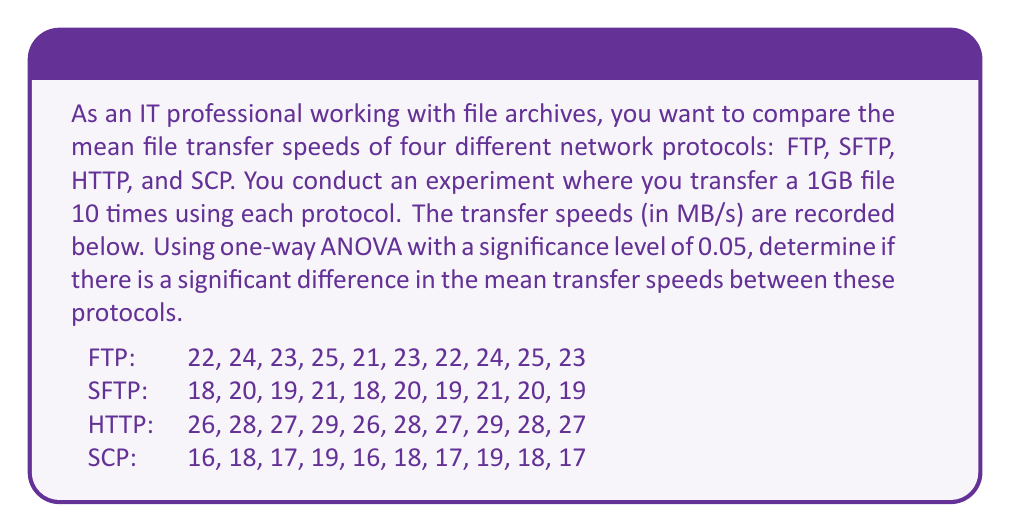Could you help me with this problem? To solve this problem using one-way ANOVA, we'll follow these steps:

1. Calculate the sum of squares between groups (SSB)
2. Calculate the sum of squares within groups (SSW)
3. Calculate the total sum of squares (SST)
4. Calculate the degrees of freedom
5. Calculate the mean squares
6. Calculate the F-statistic
7. Compare the F-statistic to the critical F-value

Step 1: Calculate SSB

First, we need to calculate the grand mean and the means for each group:

Grand mean: $\bar{X} = \frac{895}{40} = 22.375$

Group means:
FTP: $\bar{X}_1 = 23.2$
SFTP: $\bar{X}_2 = 19.5$
HTTP: $\bar{X}_3 = 27.5$
SCP: $\bar{X}_4 = 17.5$

Now we can calculate SSB:

$$SSB = \sum_{i=1}^k n_i(\bar{X}_i - \bar{X})^2$$

Where $k$ is the number of groups (4) and $n_i$ is the number of observations in each group (10).

$$SSB = 10(23.2 - 22.375)^2 + 10(19.5 - 22.375)^2 + 10(27.5 - 22.375)^2 + 10(17.5 - 22.375)^2 = 680.625$$

Step 2: Calculate SSW

$$SSW = \sum_{i=1}^k \sum_{j=1}^{n_i} (X_{ij} - \bar{X}_i)^2$$

FTP: 14
SFTP: 10
HTTP: 14
SCP: 10

$$SSW = 14 + 10 + 14 + 10 = 48$$

Step 3: Calculate SST

$$SST = SSB + SSW = 680.625 + 48 = 728.625$$

Step 4: Calculate degrees of freedom

Between groups: $df_B = k - 1 = 4 - 1 = 3$
Within groups: $df_W = N - k = 40 - 4 = 36$
Total: $df_T = N - 1 = 40 - 1 = 39$

Step 5: Calculate mean squares

$$MSB = \frac{SSB}{df_B} = \frac{680.625}{3} = 226.875$$
$$MSW = \frac{SSW}{df_W} = \frac{48}{36} = 1.333$$

Step 6: Calculate F-statistic

$$F = \frac{MSB}{MSW} = \frac{226.875}{1.333} = 170.156$$

Step 7: Compare F-statistic to critical F-value

The critical F-value for $\alpha = 0.05$, $df_B = 3$, and $df_W = 36$ is approximately 2.866.

Since our calculated F-statistic (170.156) is much larger than the critical F-value (2.866), we reject the null hypothesis.
Answer: There is a significant difference in the mean transfer speeds between the four network protocols (F(3,36) = 170.156, p < 0.05). 